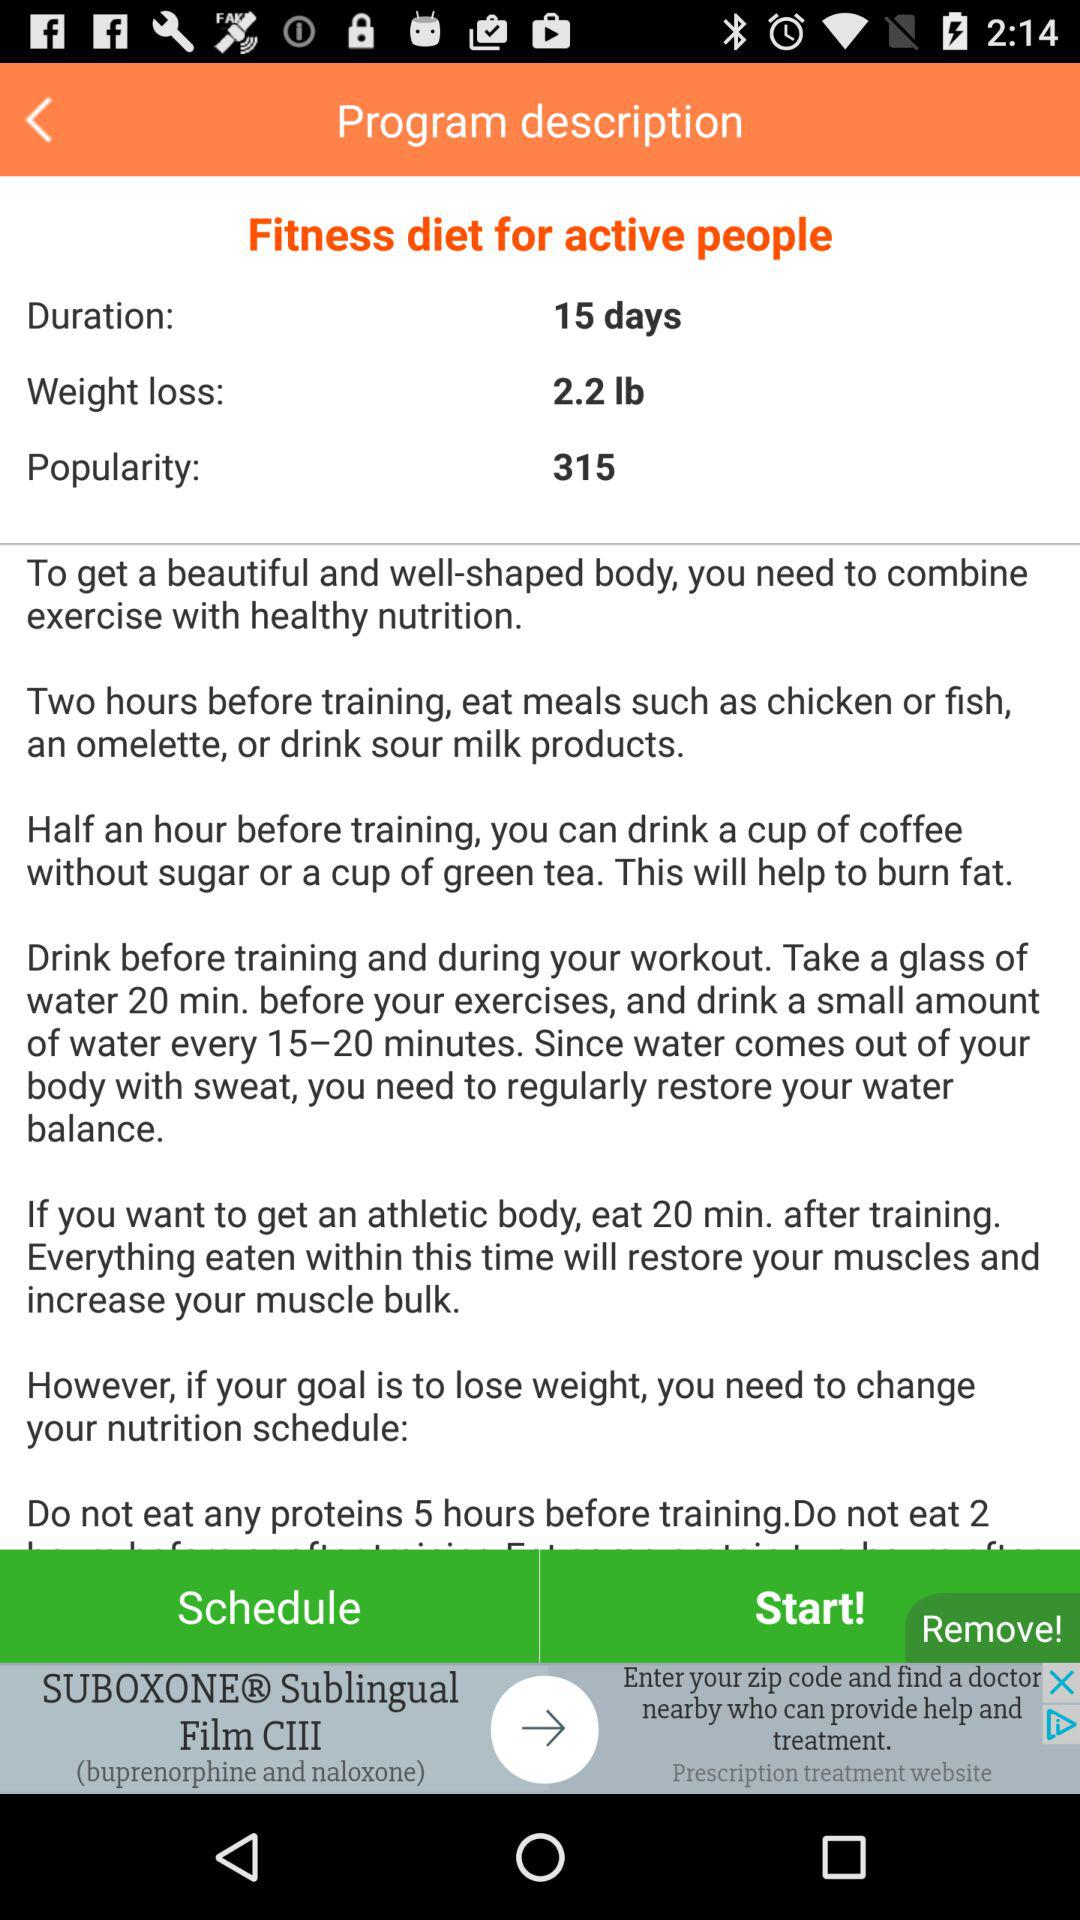How many days is the fitness diet for active people?
Answer the question using a single word or phrase. 15 days 